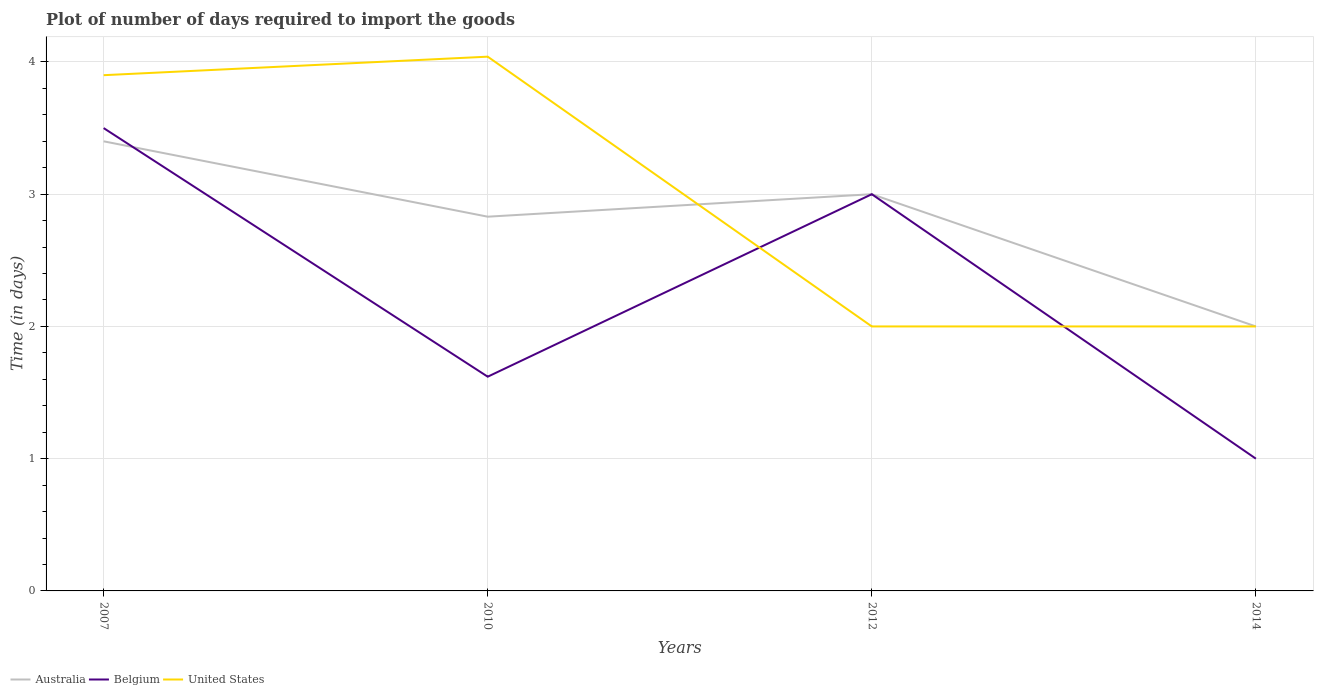Does the line corresponding to Australia intersect with the line corresponding to Belgium?
Ensure brevity in your answer.  Yes. In which year was the time required to import goods in Australia maximum?
Give a very brief answer. 2014. What is the total time required to import goods in United States in the graph?
Provide a short and direct response. 2.04. Is the time required to import goods in United States strictly greater than the time required to import goods in Australia over the years?
Provide a short and direct response. No. How many lines are there?
Provide a short and direct response. 3. How many years are there in the graph?
Give a very brief answer. 4. Where does the legend appear in the graph?
Your response must be concise. Bottom left. How many legend labels are there?
Your answer should be very brief. 3. How are the legend labels stacked?
Ensure brevity in your answer.  Horizontal. What is the title of the graph?
Offer a very short reply. Plot of number of days required to import the goods. What is the label or title of the X-axis?
Your answer should be compact. Years. What is the label or title of the Y-axis?
Provide a succinct answer. Time (in days). What is the Time (in days) of Australia in 2007?
Your answer should be compact. 3.4. What is the Time (in days) in Belgium in 2007?
Give a very brief answer. 3.5. What is the Time (in days) in Australia in 2010?
Your response must be concise. 2.83. What is the Time (in days) of Belgium in 2010?
Provide a short and direct response. 1.62. What is the Time (in days) in United States in 2010?
Your response must be concise. 4.04. What is the Time (in days) of Australia in 2012?
Provide a short and direct response. 3. What is the Time (in days) of Belgium in 2012?
Provide a succinct answer. 3. Across all years, what is the maximum Time (in days) in Australia?
Ensure brevity in your answer.  3.4. Across all years, what is the maximum Time (in days) in Belgium?
Make the answer very short. 3.5. Across all years, what is the maximum Time (in days) of United States?
Keep it short and to the point. 4.04. Across all years, what is the minimum Time (in days) in United States?
Offer a very short reply. 2. What is the total Time (in days) in Australia in the graph?
Your answer should be very brief. 11.23. What is the total Time (in days) of Belgium in the graph?
Offer a very short reply. 9.12. What is the total Time (in days) in United States in the graph?
Ensure brevity in your answer.  11.94. What is the difference between the Time (in days) in Australia in 2007 and that in 2010?
Your response must be concise. 0.57. What is the difference between the Time (in days) in Belgium in 2007 and that in 2010?
Ensure brevity in your answer.  1.88. What is the difference between the Time (in days) in United States in 2007 and that in 2010?
Provide a short and direct response. -0.14. What is the difference between the Time (in days) in Australia in 2007 and that in 2012?
Ensure brevity in your answer.  0.4. What is the difference between the Time (in days) in Belgium in 2007 and that in 2014?
Offer a very short reply. 2.5. What is the difference between the Time (in days) in United States in 2007 and that in 2014?
Ensure brevity in your answer.  1.9. What is the difference between the Time (in days) in Australia in 2010 and that in 2012?
Keep it short and to the point. -0.17. What is the difference between the Time (in days) of Belgium in 2010 and that in 2012?
Your response must be concise. -1.38. What is the difference between the Time (in days) of United States in 2010 and that in 2012?
Offer a terse response. 2.04. What is the difference between the Time (in days) in Australia in 2010 and that in 2014?
Your answer should be compact. 0.83. What is the difference between the Time (in days) of Belgium in 2010 and that in 2014?
Offer a terse response. 0.62. What is the difference between the Time (in days) of United States in 2010 and that in 2014?
Provide a short and direct response. 2.04. What is the difference between the Time (in days) of Australia in 2012 and that in 2014?
Make the answer very short. 1. What is the difference between the Time (in days) in Australia in 2007 and the Time (in days) in Belgium in 2010?
Your answer should be very brief. 1.78. What is the difference between the Time (in days) in Australia in 2007 and the Time (in days) in United States in 2010?
Make the answer very short. -0.64. What is the difference between the Time (in days) of Belgium in 2007 and the Time (in days) of United States in 2010?
Offer a very short reply. -0.54. What is the difference between the Time (in days) in Belgium in 2007 and the Time (in days) in United States in 2012?
Provide a succinct answer. 1.5. What is the difference between the Time (in days) in Australia in 2007 and the Time (in days) in Belgium in 2014?
Ensure brevity in your answer.  2.4. What is the difference between the Time (in days) of Australia in 2007 and the Time (in days) of United States in 2014?
Your answer should be compact. 1.4. What is the difference between the Time (in days) of Australia in 2010 and the Time (in days) of Belgium in 2012?
Your response must be concise. -0.17. What is the difference between the Time (in days) of Australia in 2010 and the Time (in days) of United States in 2012?
Offer a very short reply. 0.83. What is the difference between the Time (in days) of Belgium in 2010 and the Time (in days) of United States in 2012?
Provide a short and direct response. -0.38. What is the difference between the Time (in days) of Australia in 2010 and the Time (in days) of Belgium in 2014?
Make the answer very short. 1.83. What is the difference between the Time (in days) of Australia in 2010 and the Time (in days) of United States in 2014?
Ensure brevity in your answer.  0.83. What is the difference between the Time (in days) in Belgium in 2010 and the Time (in days) in United States in 2014?
Keep it short and to the point. -0.38. What is the difference between the Time (in days) in Australia in 2012 and the Time (in days) in United States in 2014?
Ensure brevity in your answer.  1. What is the average Time (in days) in Australia per year?
Offer a terse response. 2.81. What is the average Time (in days) in Belgium per year?
Give a very brief answer. 2.28. What is the average Time (in days) in United States per year?
Keep it short and to the point. 2.98. In the year 2007, what is the difference between the Time (in days) of Australia and Time (in days) of Belgium?
Give a very brief answer. -0.1. In the year 2010, what is the difference between the Time (in days) in Australia and Time (in days) in Belgium?
Your response must be concise. 1.21. In the year 2010, what is the difference between the Time (in days) of Australia and Time (in days) of United States?
Your answer should be very brief. -1.21. In the year 2010, what is the difference between the Time (in days) in Belgium and Time (in days) in United States?
Keep it short and to the point. -2.42. In the year 2012, what is the difference between the Time (in days) of Australia and Time (in days) of Belgium?
Keep it short and to the point. 0. In the year 2012, what is the difference between the Time (in days) of Australia and Time (in days) of United States?
Provide a succinct answer. 1. In the year 2014, what is the difference between the Time (in days) in Belgium and Time (in days) in United States?
Offer a very short reply. -1. What is the ratio of the Time (in days) in Australia in 2007 to that in 2010?
Offer a very short reply. 1.2. What is the ratio of the Time (in days) of Belgium in 2007 to that in 2010?
Provide a short and direct response. 2.16. What is the ratio of the Time (in days) in United States in 2007 to that in 2010?
Offer a terse response. 0.97. What is the ratio of the Time (in days) of Australia in 2007 to that in 2012?
Ensure brevity in your answer.  1.13. What is the ratio of the Time (in days) in United States in 2007 to that in 2012?
Provide a short and direct response. 1.95. What is the ratio of the Time (in days) in Australia in 2007 to that in 2014?
Give a very brief answer. 1.7. What is the ratio of the Time (in days) in United States in 2007 to that in 2014?
Your response must be concise. 1.95. What is the ratio of the Time (in days) in Australia in 2010 to that in 2012?
Your answer should be compact. 0.94. What is the ratio of the Time (in days) of Belgium in 2010 to that in 2012?
Your response must be concise. 0.54. What is the ratio of the Time (in days) in United States in 2010 to that in 2012?
Provide a short and direct response. 2.02. What is the ratio of the Time (in days) of Australia in 2010 to that in 2014?
Your answer should be very brief. 1.42. What is the ratio of the Time (in days) of Belgium in 2010 to that in 2014?
Give a very brief answer. 1.62. What is the ratio of the Time (in days) in United States in 2010 to that in 2014?
Offer a terse response. 2.02. What is the difference between the highest and the second highest Time (in days) in Australia?
Make the answer very short. 0.4. What is the difference between the highest and the second highest Time (in days) of Belgium?
Offer a terse response. 0.5. What is the difference between the highest and the second highest Time (in days) in United States?
Provide a succinct answer. 0.14. What is the difference between the highest and the lowest Time (in days) of Australia?
Ensure brevity in your answer.  1.4. What is the difference between the highest and the lowest Time (in days) in United States?
Offer a terse response. 2.04. 